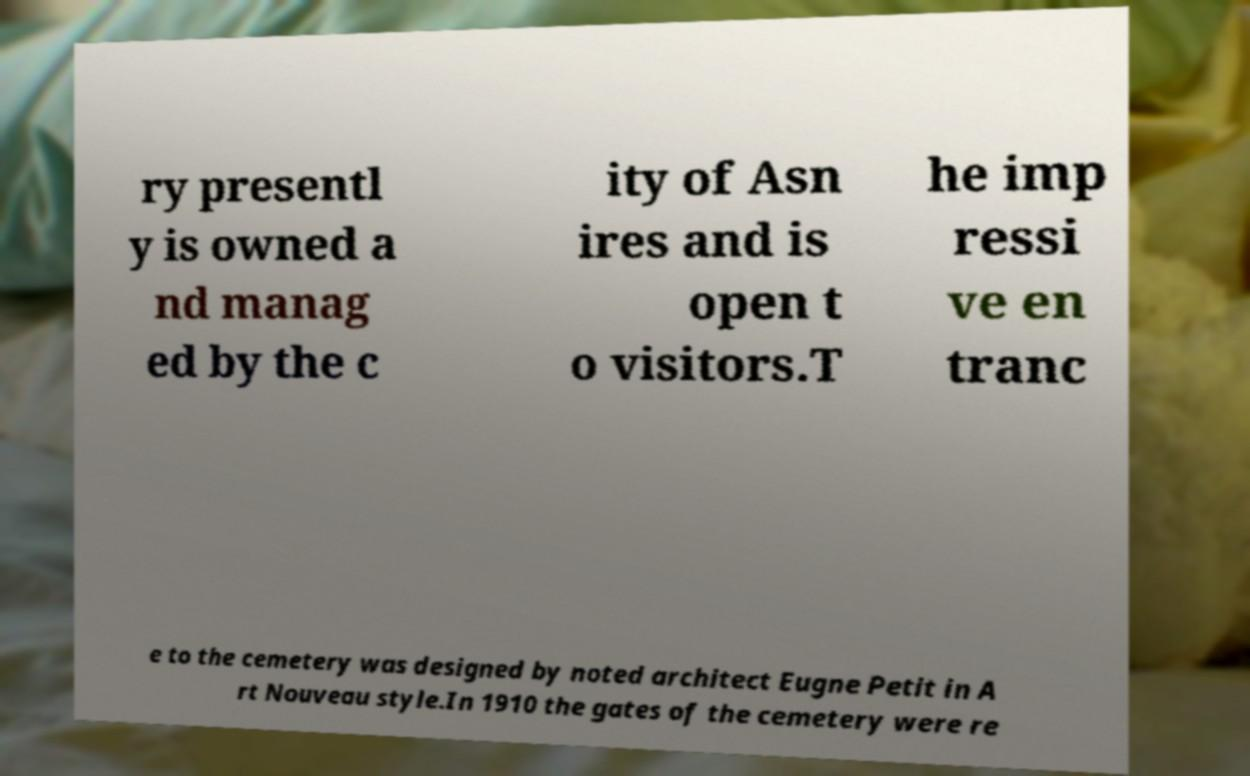Can you read and provide the text displayed in the image?This photo seems to have some interesting text. Can you extract and type it out for me? ry presentl y is owned a nd manag ed by the c ity of Asn ires and is open t o visitors.T he imp ressi ve en tranc e to the cemetery was designed by noted architect Eugne Petit in A rt Nouveau style.In 1910 the gates of the cemetery were re 